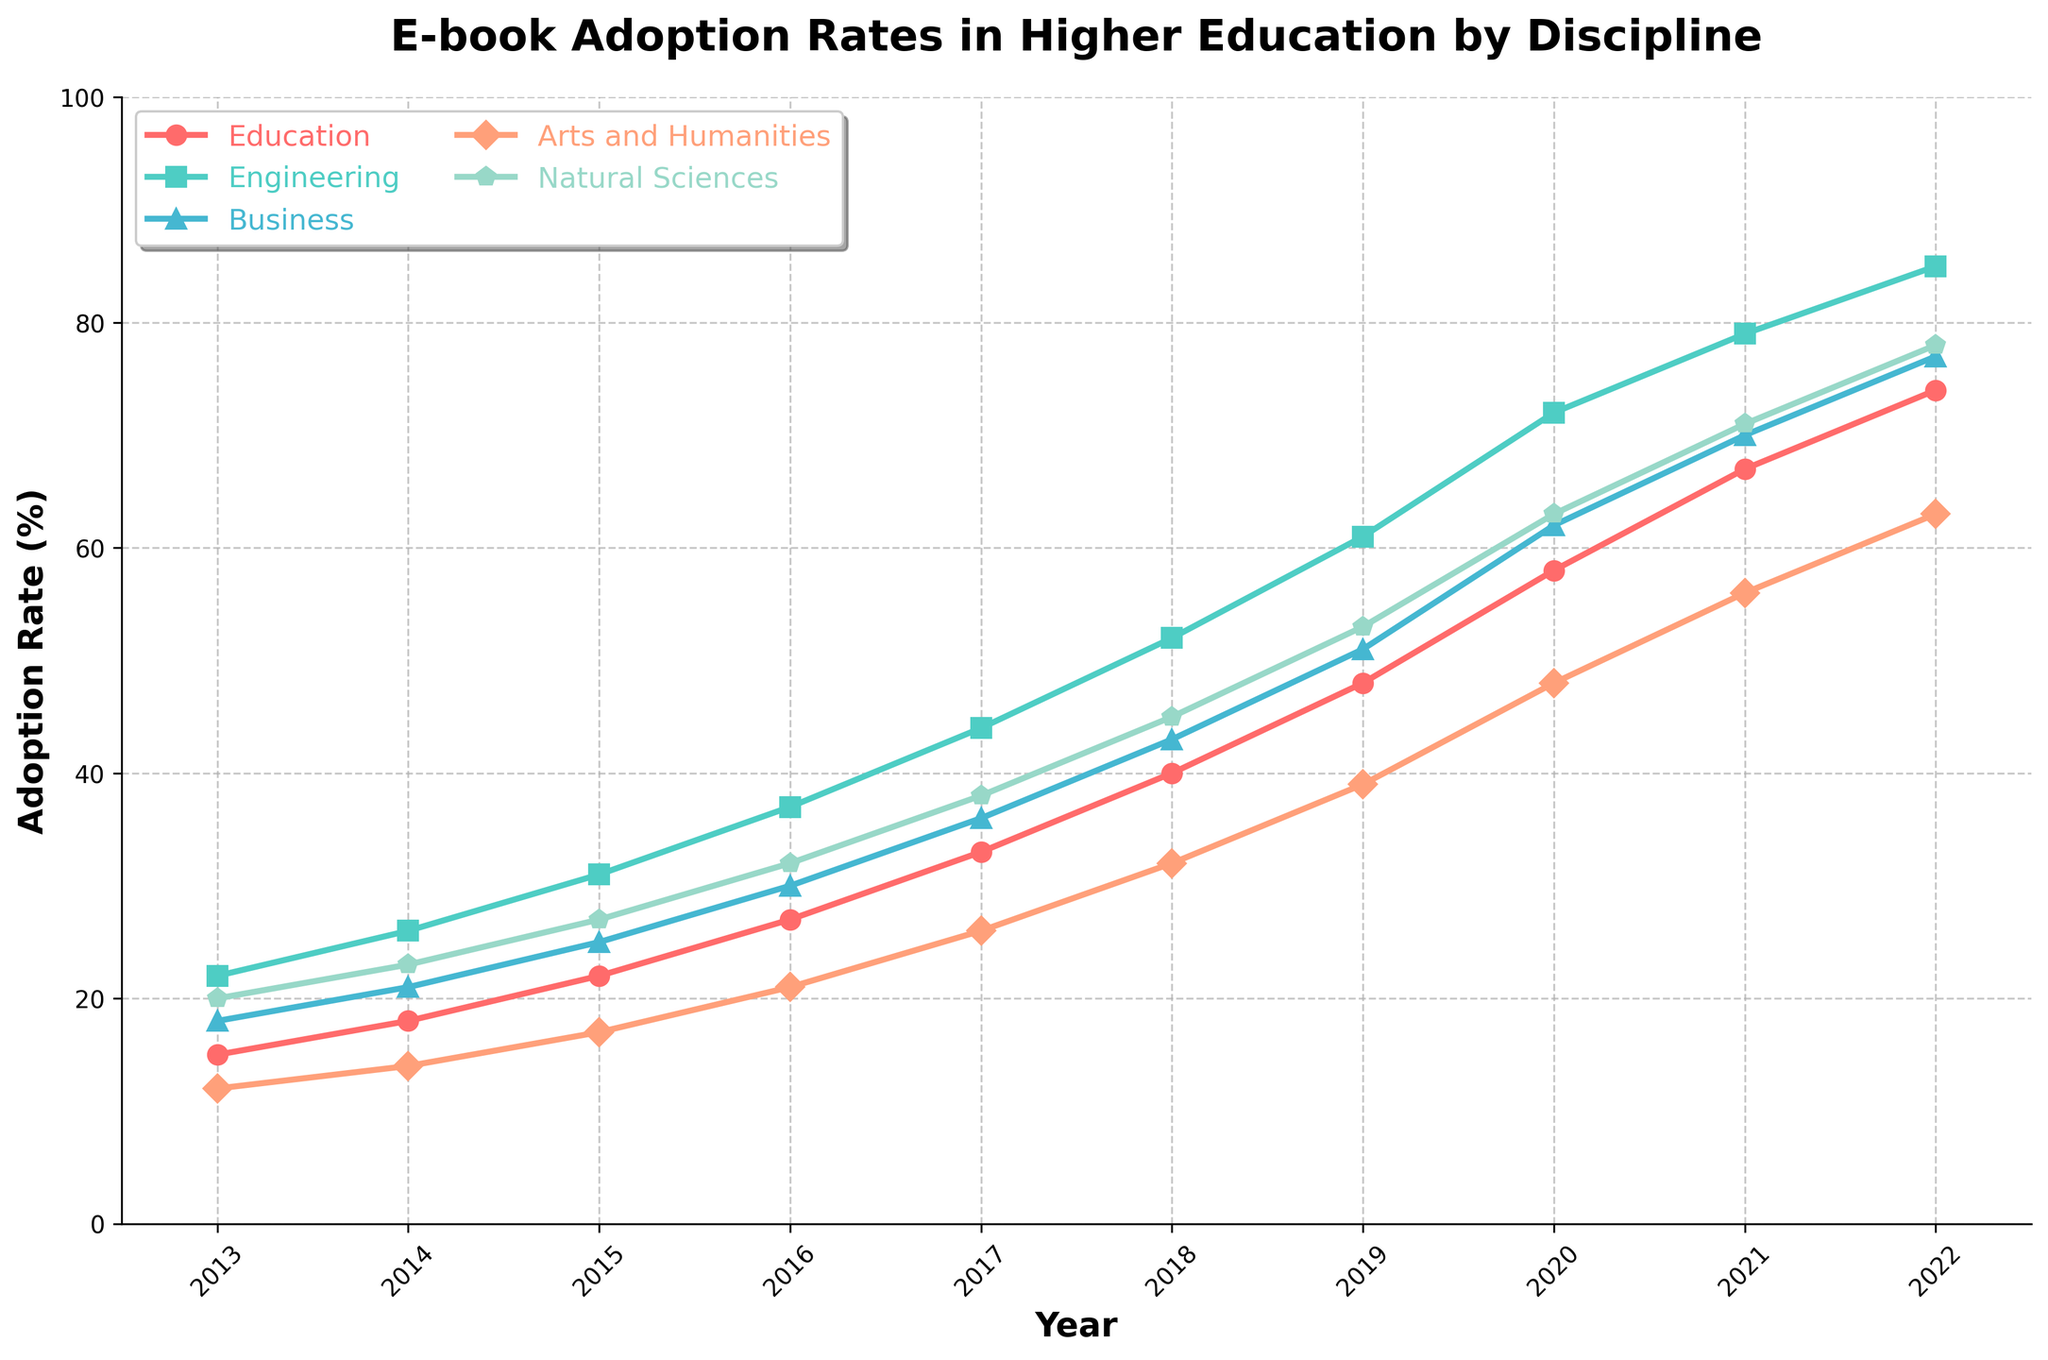What is the adoption rate of E-books for Engineering in 2020? Observing the figure, locate the 2020 point on the x-axis and trace vertically to the Engineering line, which corresponds to approximately 72% adoption.
Answer: 72% Which academic discipline had the highest E-book adoption rate in 2022? By examining the data points for 2022 across all disciplines, it is clear that Engineering has the highest value, reaching around 85%.
Answer: Engineering How did the E-book adoption rate for Education change from 2013 to 2022? Calculate the difference between the 2022 value (74%) and the 2013 value (15%) for Education. The change is 74% - 15%, which equals a 59% increase.
Answer: Increased by 59% Which two disciplines have almost equal adoption rates in 2016? Observing the graph for 2016, the adoption rates for Arts and Humanities and Natural Sciences are very close, with values approximately at 21% and 32%, respectively. Their closeness indicates nearly equal adoption.
Answer: Arts and Humanities and Natural Sciences By how much did the E-book adoption rate in Business increase from 2014 to 2017? The 2014 adoption rate for Business was 21% and in 2017 it was 36%. The increase is calculated as 36% - 21%, which equals 15%.
Answer: Increased by 15% In 2021, which disciplines had lower E-book adoption rates compared to Education? In 2021, Education has an adoption rate of 67%. By comparing this with the values for other disciplines, Arts and Humanities (56%) and Business (70%) are lower.
Answer: Arts and Humanities What is the average E-book adoption rate for Natural Sciences across the entire decade? Summing up the values for Natural Sciences from 2013 to 2022 (20 + 23 + 27 + 32 + 38 + 45 + 53 + 63 + 71 + 78) results in 450. Dividing this sum by the number of years (10), the average is 450 / 10 = 45%.
Answer: 45% Did any discipline experience a year-over-year decrease in E-book adoption? Observing the trend lines for all disciplines, each shows a consistent upward trajectory with no decreases year-over-year.
Answer: No Which discipline showed the most rapid growth in E-book adoption from 2018 to 2020? Comparing the increase between 2018 and 2020 for each discipline, Engineering shows the largest jump (72% - 52% = 20%).
Answer: Engineering 